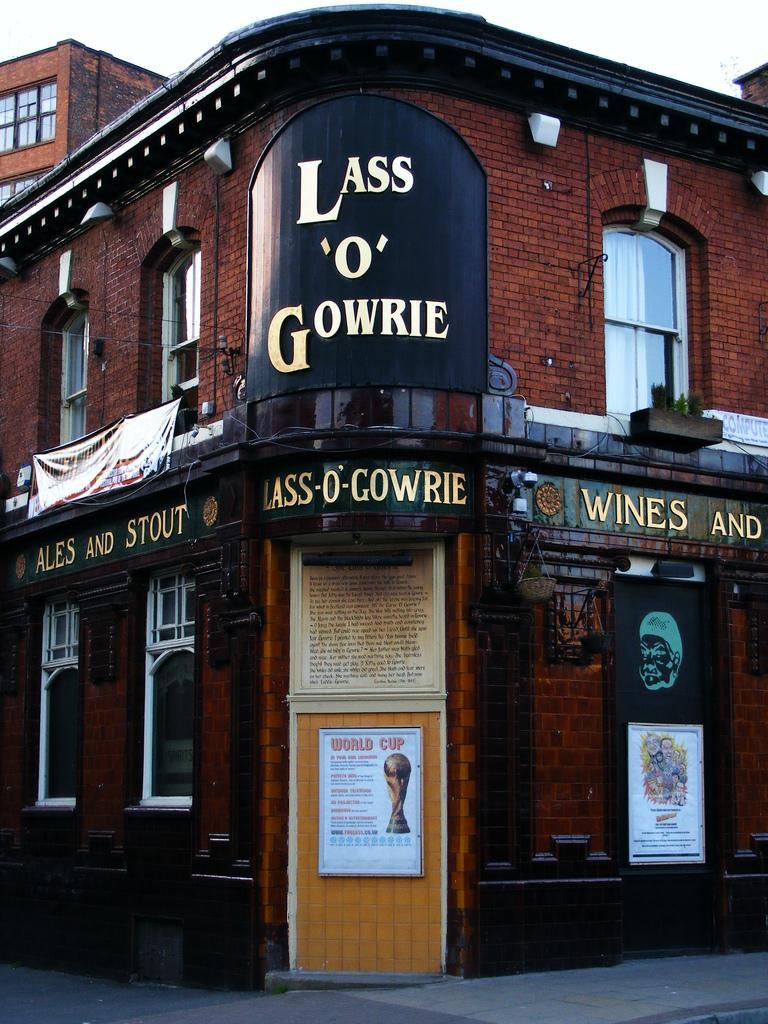Could you give a brief overview of what you see in this image? In this image, we can see a building. There is a door at the bottom of the image. There is a sky at the top of the image. 